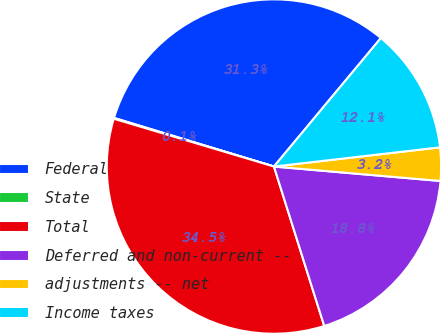<chart> <loc_0><loc_0><loc_500><loc_500><pie_chart><fcel>Federal<fcel>State<fcel>Total<fcel>Deferred and non-current --<fcel>adjustments -- net<fcel>Income taxes<nl><fcel>31.35%<fcel>0.08%<fcel>34.48%<fcel>18.76%<fcel>3.21%<fcel>12.12%<nl></chart> 